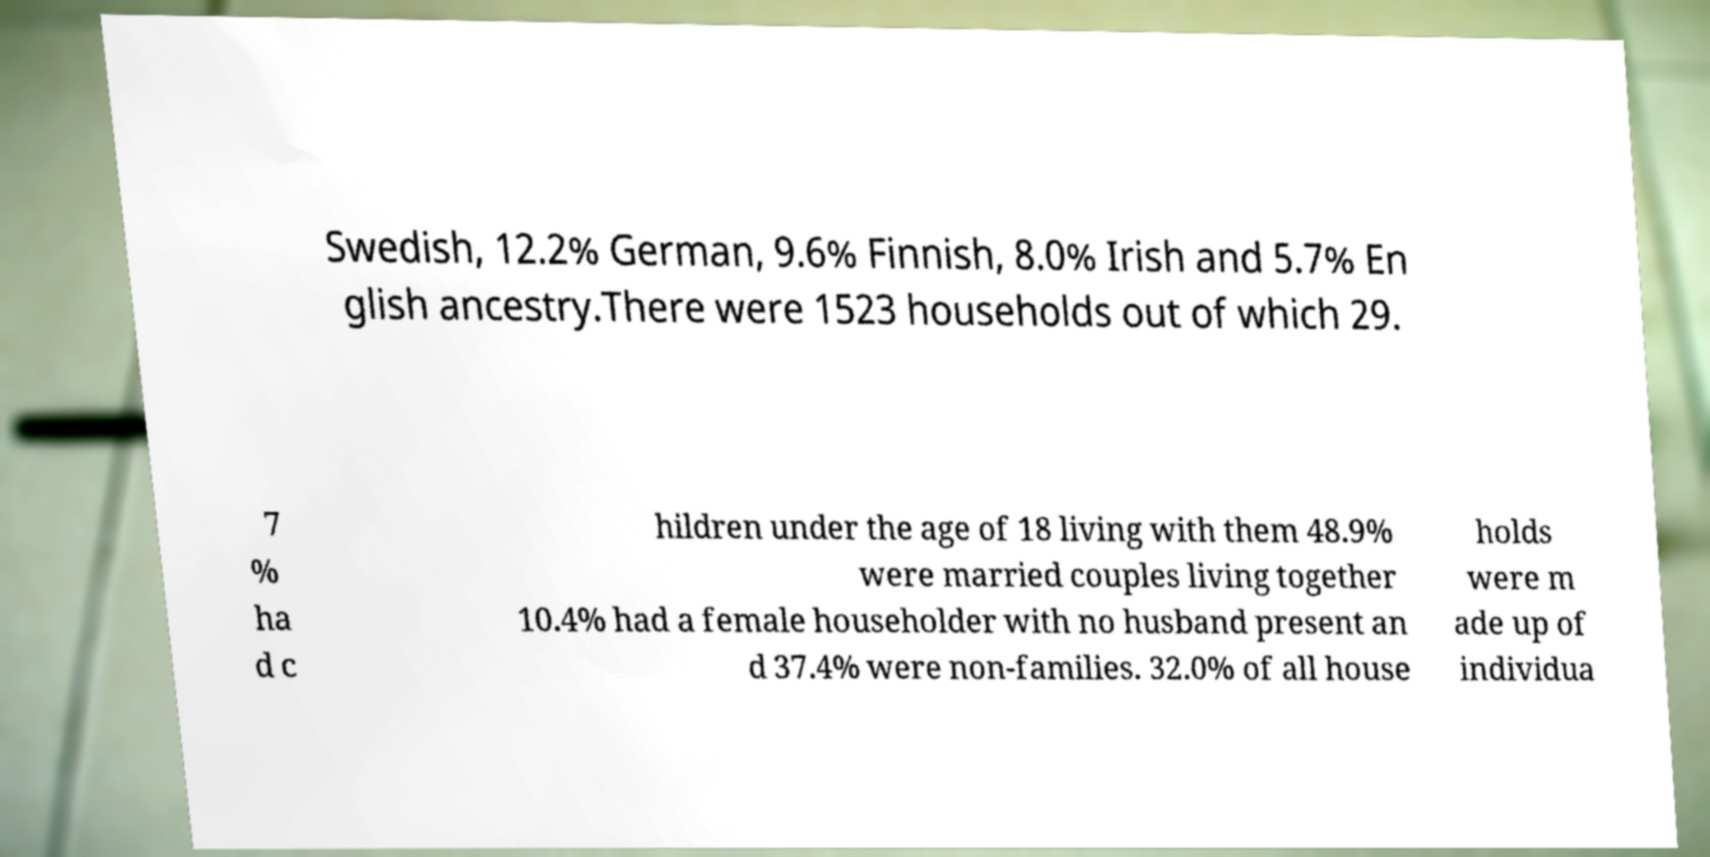For documentation purposes, I need the text within this image transcribed. Could you provide that? Swedish, 12.2% German, 9.6% Finnish, 8.0% Irish and 5.7% En glish ancestry.There were 1523 households out of which 29. 7 % ha d c hildren under the age of 18 living with them 48.9% were married couples living together 10.4% had a female householder with no husband present an d 37.4% were non-families. 32.0% of all house holds were m ade up of individua 